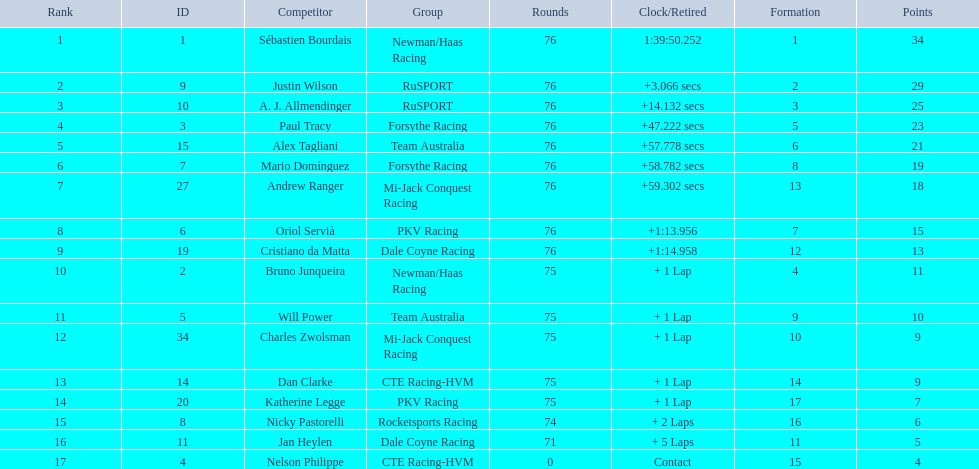What was alex taglini's final score in the tecate grand prix? 21. What was paul tracy's final score in the tecate grand prix? 23. Which driver finished first? Paul Tracy. 